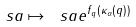<formula> <loc_0><loc_0><loc_500><loc_500>\ s a \mapsto \ s a e ^ { f _ { q } ( \kappa _ { \alpha } ( q ) ) }</formula> 